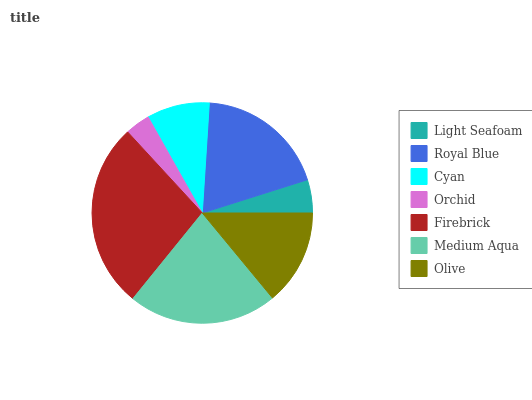Is Orchid the minimum?
Answer yes or no. Yes. Is Firebrick the maximum?
Answer yes or no. Yes. Is Royal Blue the minimum?
Answer yes or no. No. Is Royal Blue the maximum?
Answer yes or no. No. Is Royal Blue greater than Light Seafoam?
Answer yes or no. Yes. Is Light Seafoam less than Royal Blue?
Answer yes or no. Yes. Is Light Seafoam greater than Royal Blue?
Answer yes or no. No. Is Royal Blue less than Light Seafoam?
Answer yes or no. No. Is Olive the high median?
Answer yes or no. Yes. Is Olive the low median?
Answer yes or no. Yes. Is Medium Aqua the high median?
Answer yes or no. No. Is Medium Aqua the low median?
Answer yes or no. No. 